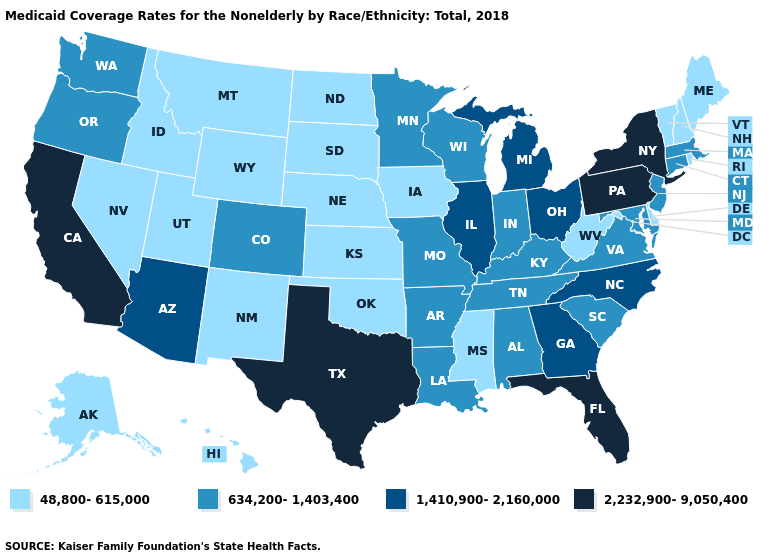What is the lowest value in the Northeast?
Write a very short answer. 48,800-615,000. Among the states that border New Mexico , does Arizona have the lowest value?
Short answer required. No. Does Arizona have the highest value in the West?
Concise answer only. No. Does Hawaii have the highest value in the USA?
Write a very short answer. No. Name the states that have a value in the range 634,200-1,403,400?
Write a very short answer. Alabama, Arkansas, Colorado, Connecticut, Indiana, Kentucky, Louisiana, Maryland, Massachusetts, Minnesota, Missouri, New Jersey, Oregon, South Carolina, Tennessee, Virginia, Washington, Wisconsin. What is the lowest value in the MidWest?
Concise answer only. 48,800-615,000. How many symbols are there in the legend?
Short answer required. 4. What is the value of Utah?
Give a very brief answer. 48,800-615,000. What is the value of Arizona?
Be succinct. 1,410,900-2,160,000. Name the states that have a value in the range 2,232,900-9,050,400?
Be succinct. California, Florida, New York, Pennsylvania, Texas. What is the highest value in the USA?
Give a very brief answer. 2,232,900-9,050,400. Does Illinois have a lower value than Arkansas?
Answer briefly. No. What is the value of Pennsylvania?
Be succinct. 2,232,900-9,050,400. Among the states that border Mississippi , which have the lowest value?
Concise answer only. Alabama, Arkansas, Louisiana, Tennessee. 